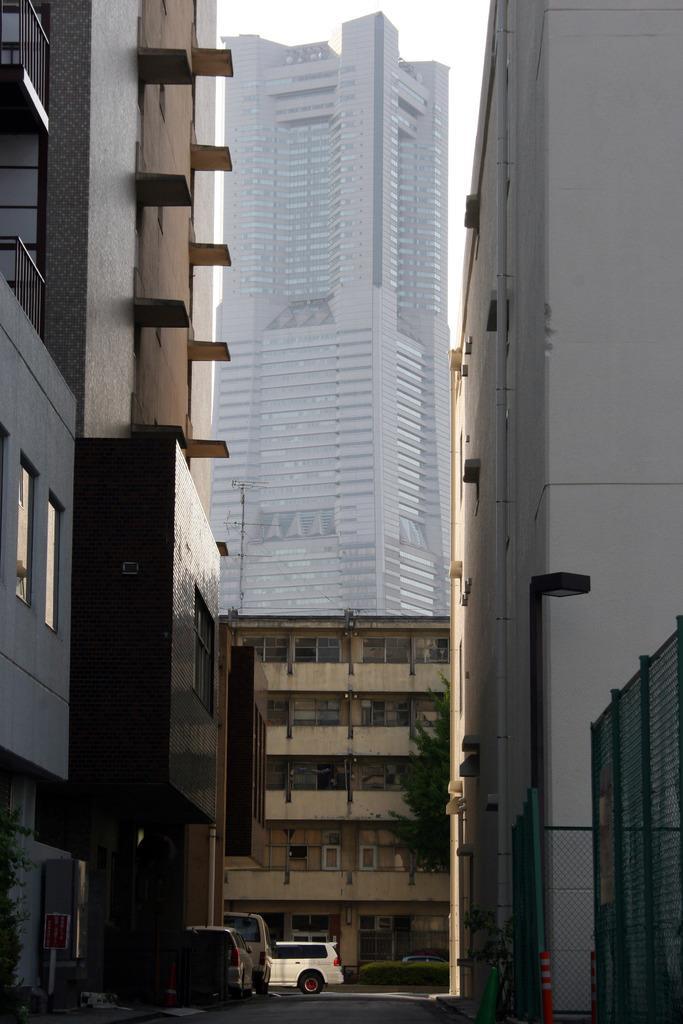Can you describe this image briefly? In this image, we can see some buildings and there is a street, at the middle we can see some cars. 